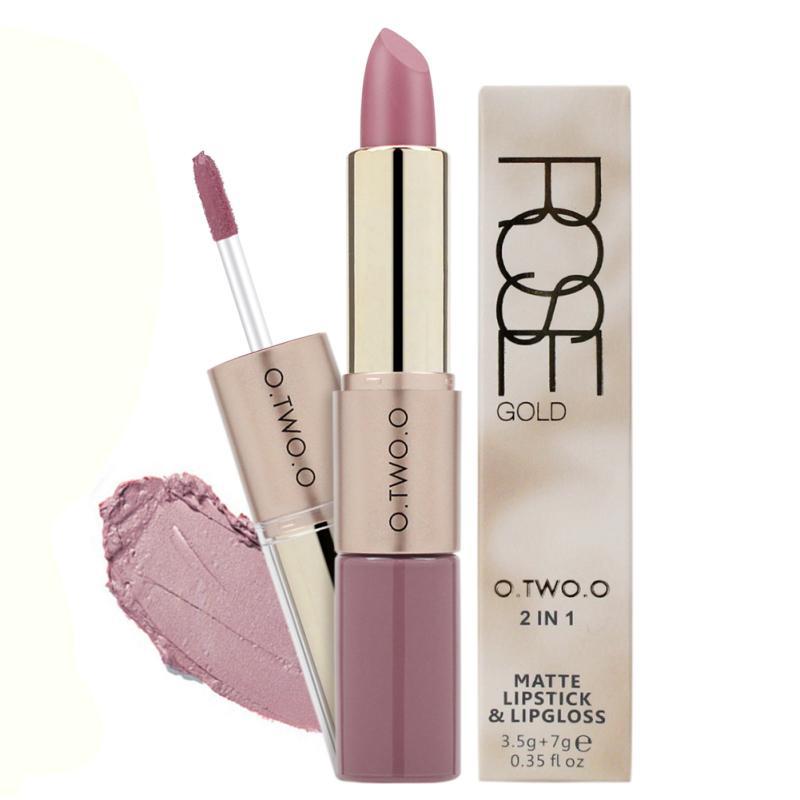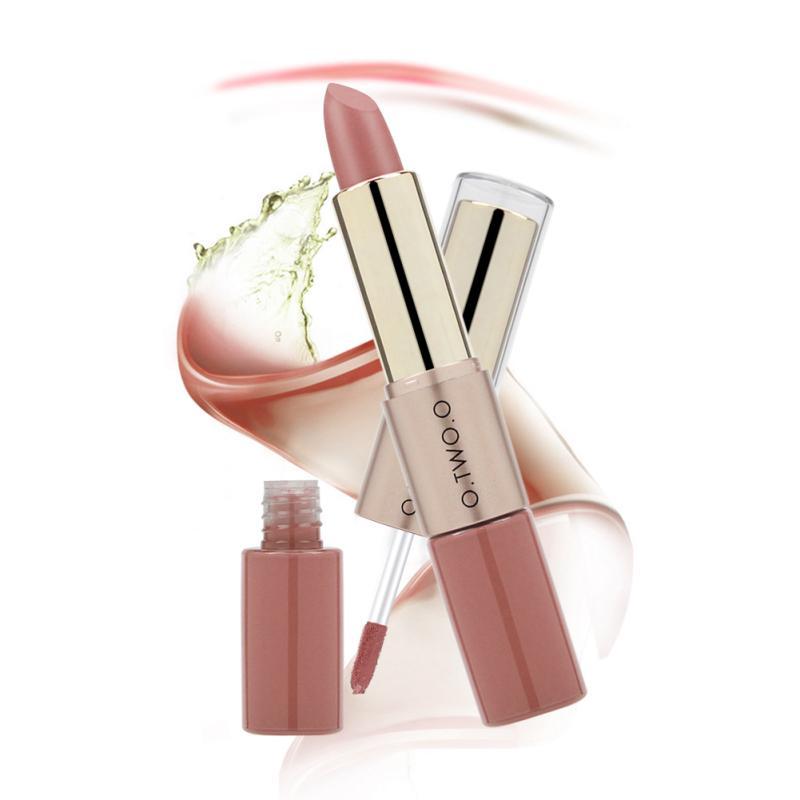The first image is the image on the left, the second image is the image on the right. Evaluate the accuracy of this statement regarding the images: "All of the products are exactly vertical.". Is it true? Answer yes or no. No. 